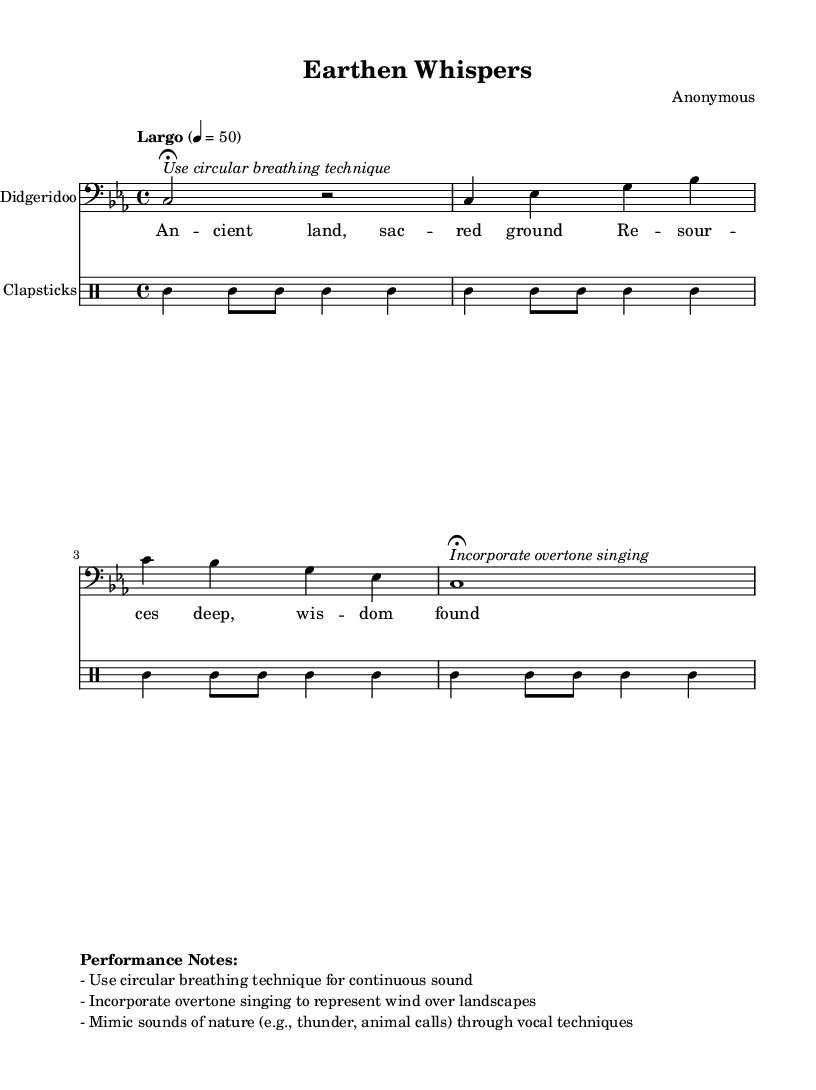What is the key signature of this music? The key signature is indicated at the beginning of the score and shows that the piece is in C minor, which has three flat notes (B flat, E flat, and A flat).
Answer: C minor What is the time signature of this music? The time signature is found at the beginning of the score, showing that this piece is written in 4/4 time, meaning there are four beats in a measure.
Answer: 4/4 What is the tempo marking for the piece? The tempo marking is indicated in Italian above the staff, specifying "Largo," which means to play slowly, and it also includes the beats per minute as 50.
Answer: Largo How many measures are there in the didgeridoo part? Counting the measures in the didgeridoo part, there are a total of five measures, as defined by the vertical lines separating the musical phrases.
Answer: Five What technique is suggested for playing the didgeridoo? The performance notes indicate a specific technique to be used, which is circular breathing, allowing for continuous sound while playing the instrument.
Answer: Circular breathing What is the primary theme represented in the lyrics? The lyrics express themes related to ancient wisdom and the connection to nature and resources, as indicated by phrases like "sacred ground" and "wisdom found."
Answer: Ancient land, sacred ground What is the accompanying instrument used alongside the didgeridoo? The only percussion instrument accompanying the didgeridoo in this composition is clapsticks, which are used to create rhythmic support for the melody.
Answer: Clapsticks 